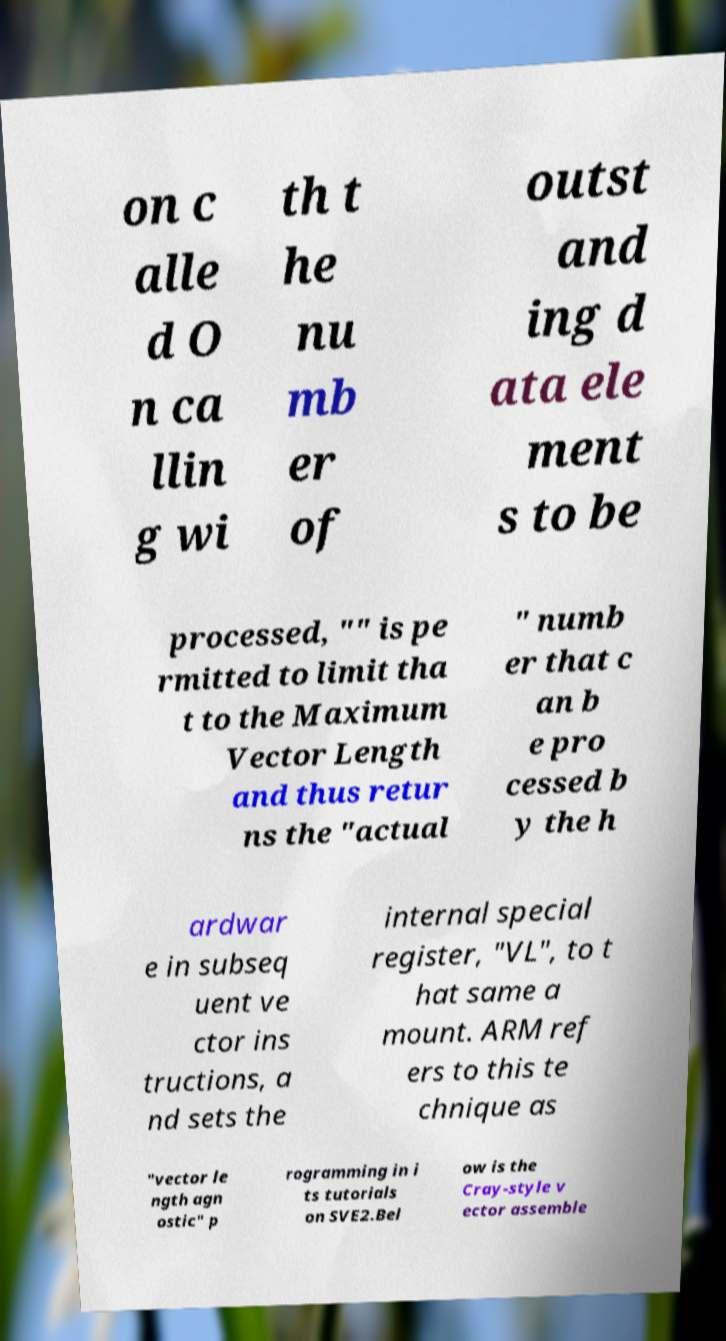I need the written content from this picture converted into text. Can you do that? on c alle d O n ca llin g wi th t he nu mb er of outst and ing d ata ele ment s to be processed, "" is pe rmitted to limit tha t to the Maximum Vector Length and thus retur ns the "actual " numb er that c an b e pro cessed b y the h ardwar e in subseq uent ve ctor ins tructions, a nd sets the internal special register, "VL", to t hat same a mount. ARM ref ers to this te chnique as "vector le ngth agn ostic" p rogramming in i ts tutorials on SVE2.Bel ow is the Cray-style v ector assemble 